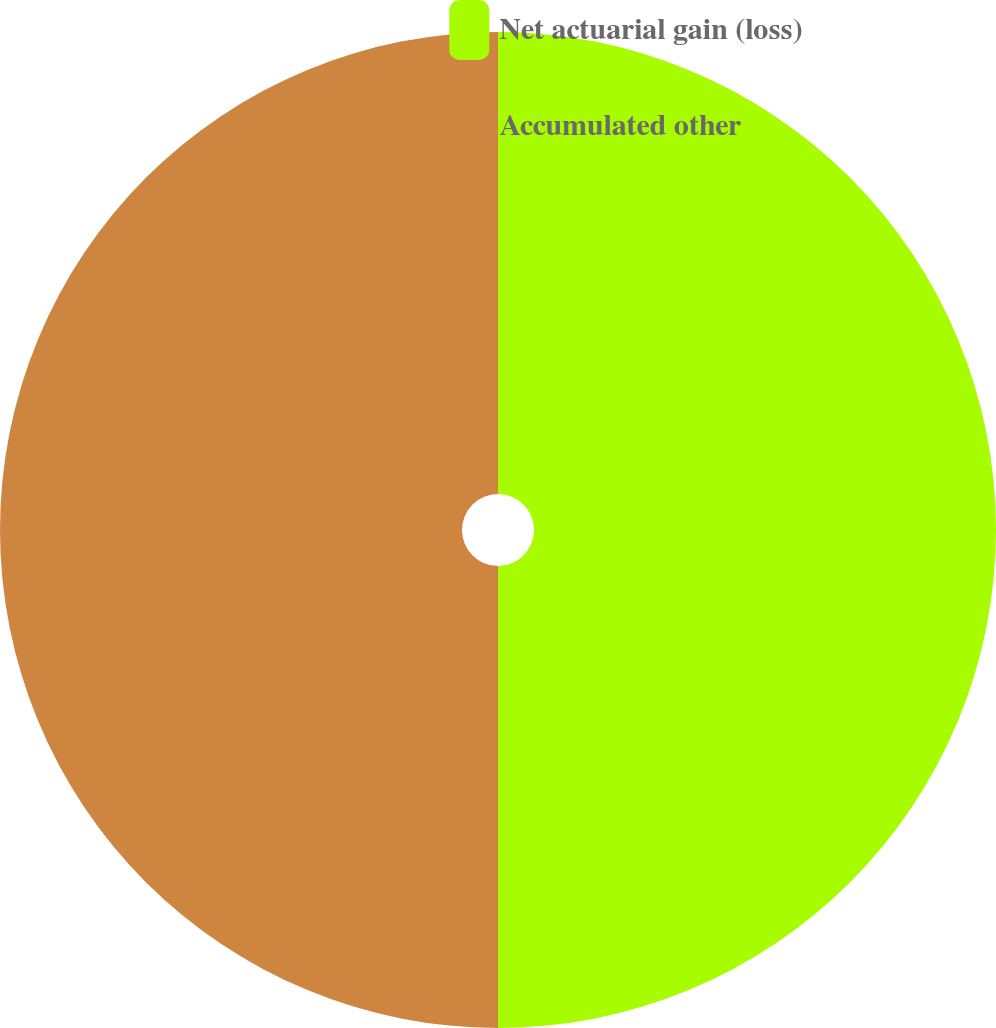Convert chart. <chart><loc_0><loc_0><loc_500><loc_500><pie_chart><fcel>Net actuarial gain (loss)<fcel>Accumulated other<nl><fcel>50.0%<fcel>50.0%<nl></chart> 